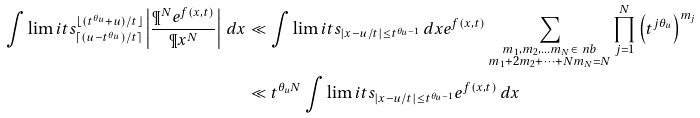Convert formula to latex. <formula><loc_0><loc_0><loc_500><loc_500>\int \lim i t s _ { \lceil ( u - t ^ { \theta _ { u } } ) / t \rceil } ^ { \lfloor ( t ^ { \theta _ { u } } + u ) / t \rfloor } \left | \frac { \P ^ { N } e ^ { f ( x , t ) } } { \P x ^ { N } } \right | \, d x & \ll \int \lim i t s _ { | x - u / t | \leq t ^ { \theta _ { u } - 1 } } \, d x e ^ { f ( x , t ) } \sum _ { \substack { m _ { 1 } , m _ { 2 } , \dots m _ { N } \in \ n b \\ m _ { 1 } + 2 m _ { 2 } + \dots + N m _ { N } = N } } \prod _ { j = 1 } ^ { N } \left ( t ^ { j \theta _ { u } } \right ) ^ { m _ { j } } \\ & \ll t ^ { \theta _ { u } N } \int \lim i t s _ { | x - u / t | \leq t ^ { \theta _ { u } - 1 } } e ^ { f ( x , t ) } \, d x</formula> 